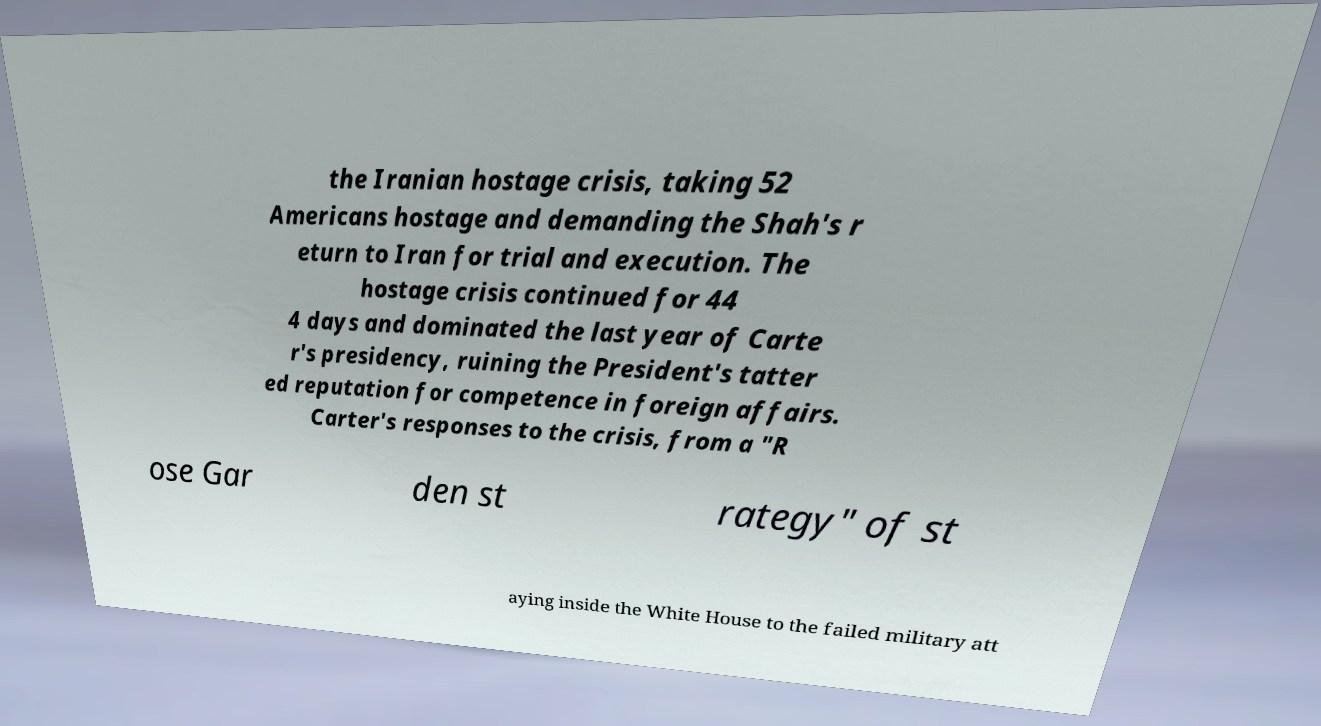Please read and relay the text visible in this image. What does it say? the Iranian hostage crisis, taking 52 Americans hostage and demanding the Shah's r eturn to Iran for trial and execution. The hostage crisis continued for 44 4 days and dominated the last year of Carte r's presidency, ruining the President's tatter ed reputation for competence in foreign affairs. Carter's responses to the crisis, from a "R ose Gar den st rategy" of st aying inside the White House to the failed military att 